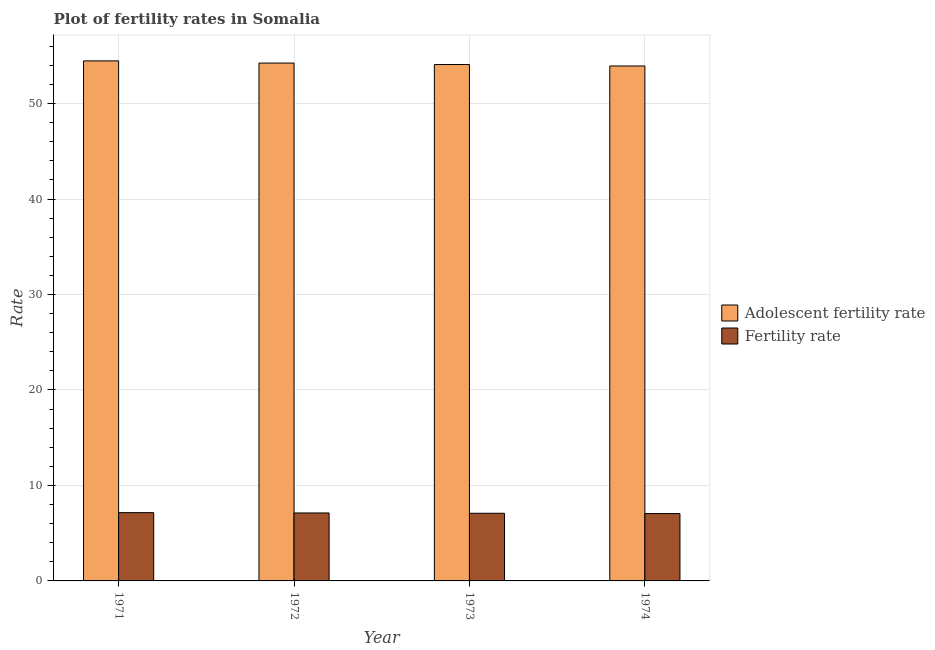How many different coloured bars are there?
Your answer should be very brief. 2. How many groups of bars are there?
Ensure brevity in your answer.  4. Are the number of bars per tick equal to the number of legend labels?
Your response must be concise. Yes. Are the number of bars on each tick of the X-axis equal?
Keep it short and to the point. Yes. How many bars are there on the 3rd tick from the right?
Your answer should be compact. 2. What is the label of the 4th group of bars from the left?
Make the answer very short. 1974. In how many cases, is the number of bars for a given year not equal to the number of legend labels?
Your response must be concise. 0. What is the adolescent fertility rate in 1971?
Ensure brevity in your answer.  54.47. Across all years, what is the maximum adolescent fertility rate?
Offer a very short reply. 54.47. Across all years, what is the minimum fertility rate?
Your answer should be very brief. 7.06. In which year was the adolescent fertility rate maximum?
Make the answer very short. 1971. In which year was the fertility rate minimum?
Provide a short and direct response. 1974. What is the total adolescent fertility rate in the graph?
Your response must be concise. 216.74. What is the difference between the fertility rate in 1971 and that in 1972?
Provide a short and direct response. 0.03. What is the difference between the fertility rate in 1972 and the adolescent fertility rate in 1974?
Your response must be concise. 0.06. What is the average fertility rate per year?
Offer a terse response. 7.1. What is the ratio of the adolescent fertility rate in 1971 to that in 1973?
Provide a succinct answer. 1.01. Is the fertility rate in 1971 less than that in 1973?
Make the answer very short. No. What is the difference between the highest and the second highest fertility rate?
Make the answer very short. 0.03. What is the difference between the highest and the lowest fertility rate?
Your answer should be compact. 0.09. In how many years, is the adolescent fertility rate greater than the average adolescent fertility rate taken over all years?
Make the answer very short. 2. Is the sum of the fertility rate in 1971 and 1974 greater than the maximum adolescent fertility rate across all years?
Your response must be concise. Yes. What does the 1st bar from the left in 1974 represents?
Give a very brief answer. Adolescent fertility rate. What does the 2nd bar from the right in 1974 represents?
Offer a very short reply. Adolescent fertility rate. How many bars are there?
Your answer should be very brief. 8. Are all the bars in the graph horizontal?
Your answer should be compact. No. Are the values on the major ticks of Y-axis written in scientific E-notation?
Your answer should be compact. No. Does the graph contain any zero values?
Offer a very short reply. No. Where does the legend appear in the graph?
Give a very brief answer. Center right. What is the title of the graph?
Your answer should be very brief. Plot of fertility rates in Somalia. Does "constant 2005 US$" appear as one of the legend labels in the graph?
Keep it short and to the point. No. What is the label or title of the Y-axis?
Provide a succinct answer. Rate. What is the Rate of Adolescent fertility rate in 1971?
Give a very brief answer. 54.47. What is the Rate in Fertility rate in 1971?
Your answer should be compact. 7.15. What is the Rate of Adolescent fertility rate in 1972?
Provide a succinct answer. 54.24. What is the Rate of Fertility rate in 1972?
Provide a succinct answer. 7.12. What is the Rate of Adolescent fertility rate in 1973?
Your answer should be compact. 54.09. What is the Rate of Fertility rate in 1973?
Give a very brief answer. 7.09. What is the Rate in Adolescent fertility rate in 1974?
Give a very brief answer. 53.94. What is the Rate of Fertility rate in 1974?
Your response must be concise. 7.06. Across all years, what is the maximum Rate of Adolescent fertility rate?
Provide a succinct answer. 54.47. Across all years, what is the maximum Rate of Fertility rate?
Make the answer very short. 7.15. Across all years, what is the minimum Rate of Adolescent fertility rate?
Provide a short and direct response. 53.94. Across all years, what is the minimum Rate in Fertility rate?
Provide a short and direct response. 7.06. What is the total Rate in Adolescent fertility rate in the graph?
Your answer should be compact. 216.74. What is the total Rate in Fertility rate in the graph?
Your answer should be very brief. 28.41. What is the difference between the Rate in Adolescent fertility rate in 1971 and that in 1972?
Your answer should be very brief. 0.23. What is the difference between the Rate of Fertility rate in 1971 and that in 1972?
Offer a very short reply. 0.03. What is the difference between the Rate of Adolescent fertility rate in 1971 and that in 1973?
Make the answer very short. 0.38. What is the difference between the Rate of Fertility rate in 1971 and that in 1973?
Ensure brevity in your answer.  0.07. What is the difference between the Rate of Adolescent fertility rate in 1971 and that in 1974?
Offer a very short reply. 0.53. What is the difference between the Rate of Fertility rate in 1971 and that in 1974?
Provide a succinct answer. 0.09. What is the difference between the Rate in Adolescent fertility rate in 1972 and that in 1973?
Provide a succinct answer. 0.15. What is the difference between the Rate in Fertility rate in 1972 and that in 1973?
Provide a short and direct response. 0.03. What is the difference between the Rate in Adolescent fertility rate in 1972 and that in 1974?
Keep it short and to the point. 0.31. What is the difference between the Rate of Fertility rate in 1972 and that in 1974?
Give a very brief answer. 0.06. What is the difference between the Rate in Adolescent fertility rate in 1973 and that in 1974?
Offer a terse response. 0.15. What is the difference between the Rate of Fertility rate in 1973 and that in 1974?
Provide a short and direct response. 0.03. What is the difference between the Rate in Adolescent fertility rate in 1971 and the Rate in Fertility rate in 1972?
Give a very brief answer. 47.35. What is the difference between the Rate in Adolescent fertility rate in 1971 and the Rate in Fertility rate in 1973?
Provide a short and direct response. 47.39. What is the difference between the Rate of Adolescent fertility rate in 1971 and the Rate of Fertility rate in 1974?
Offer a very short reply. 47.42. What is the difference between the Rate of Adolescent fertility rate in 1972 and the Rate of Fertility rate in 1973?
Offer a very short reply. 47.16. What is the difference between the Rate of Adolescent fertility rate in 1972 and the Rate of Fertility rate in 1974?
Provide a succinct answer. 47.19. What is the difference between the Rate in Adolescent fertility rate in 1973 and the Rate in Fertility rate in 1974?
Provide a succinct answer. 47.03. What is the average Rate of Adolescent fertility rate per year?
Make the answer very short. 54.19. What is the average Rate of Fertility rate per year?
Your response must be concise. 7.1. In the year 1971, what is the difference between the Rate of Adolescent fertility rate and Rate of Fertility rate?
Your answer should be very brief. 47.32. In the year 1972, what is the difference between the Rate of Adolescent fertility rate and Rate of Fertility rate?
Give a very brief answer. 47.12. In the year 1973, what is the difference between the Rate in Adolescent fertility rate and Rate in Fertility rate?
Your answer should be very brief. 47. In the year 1974, what is the difference between the Rate of Adolescent fertility rate and Rate of Fertility rate?
Offer a very short reply. 46.88. What is the ratio of the Rate in Fertility rate in 1971 to that in 1972?
Keep it short and to the point. 1. What is the ratio of the Rate in Adolescent fertility rate in 1971 to that in 1973?
Your answer should be very brief. 1.01. What is the ratio of the Rate of Fertility rate in 1971 to that in 1973?
Your answer should be compact. 1.01. What is the ratio of the Rate in Adolescent fertility rate in 1971 to that in 1974?
Make the answer very short. 1.01. What is the ratio of the Rate of Fertility rate in 1971 to that in 1974?
Your response must be concise. 1.01. What is the ratio of the Rate of Fertility rate in 1972 to that in 1974?
Your response must be concise. 1.01. What is the ratio of the Rate in Adolescent fertility rate in 1973 to that in 1974?
Your response must be concise. 1. What is the ratio of the Rate of Fertility rate in 1973 to that in 1974?
Your answer should be very brief. 1. What is the difference between the highest and the second highest Rate in Adolescent fertility rate?
Give a very brief answer. 0.23. What is the difference between the highest and the second highest Rate in Fertility rate?
Provide a succinct answer. 0.03. What is the difference between the highest and the lowest Rate of Adolescent fertility rate?
Give a very brief answer. 0.53. What is the difference between the highest and the lowest Rate of Fertility rate?
Ensure brevity in your answer.  0.09. 